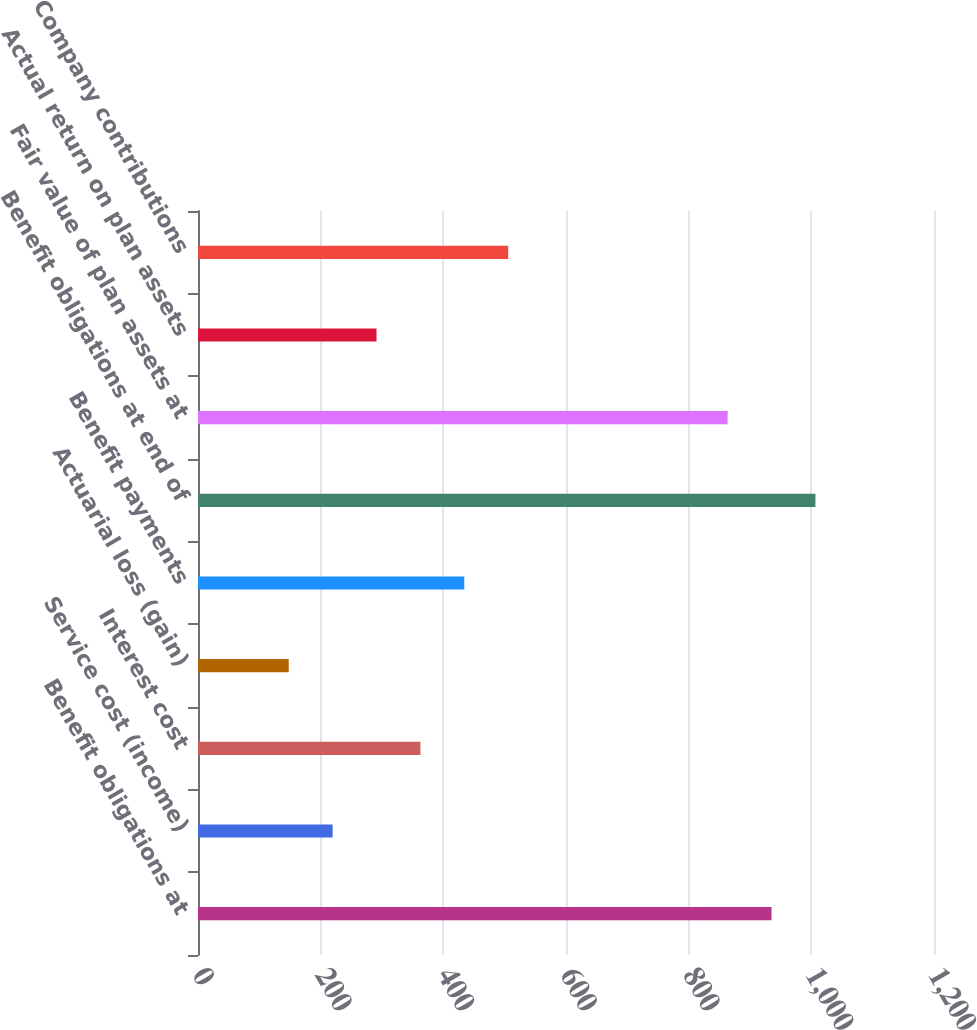<chart> <loc_0><loc_0><loc_500><loc_500><bar_chart><fcel>Benefit obligations at<fcel>Service cost (income)<fcel>Interest cost<fcel>Actuarial loss (gain)<fcel>Benefit payments<fcel>Benefit obligations at end of<fcel>Fair value of plan assets at<fcel>Actual return on plan assets<fcel>Company contributions<nl><fcel>935.1<fcel>219.5<fcel>362.62<fcel>147.94<fcel>434.18<fcel>1006.66<fcel>863.54<fcel>291.06<fcel>505.74<nl></chart> 